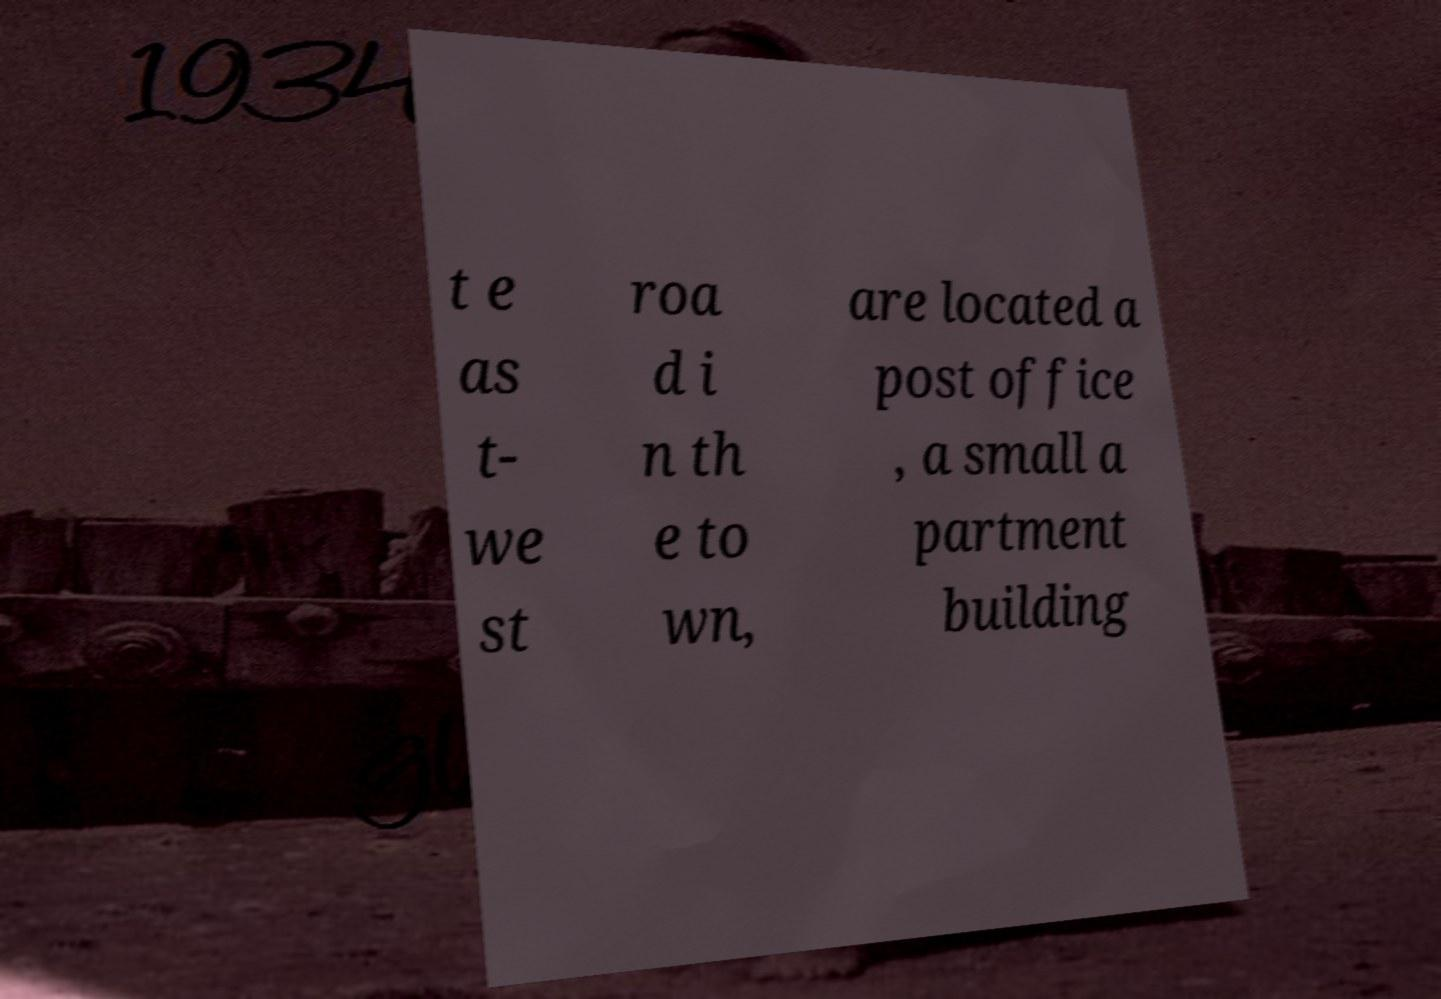Please identify and transcribe the text found in this image. t e as t- we st roa d i n th e to wn, are located a post office , a small a partment building 